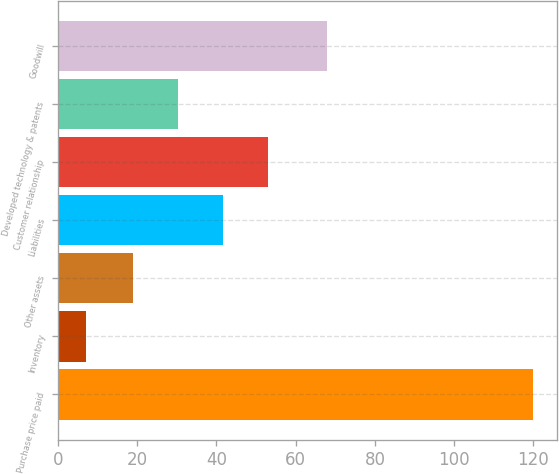Convert chart to OTSL. <chart><loc_0><loc_0><loc_500><loc_500><bar_chart><fcel>Purchase price paid<fcel>Inventory<fcel>Other assets<fcel>Liabilities<fcel>Customer relationship<fcel>Developed technology & patents<fcel>Goodwill<nl><fcel>120<fcel>7<fcel>19<fcel>41.6<fcel>52.9<fcel>30.3<fcel>68<nl></chart> 